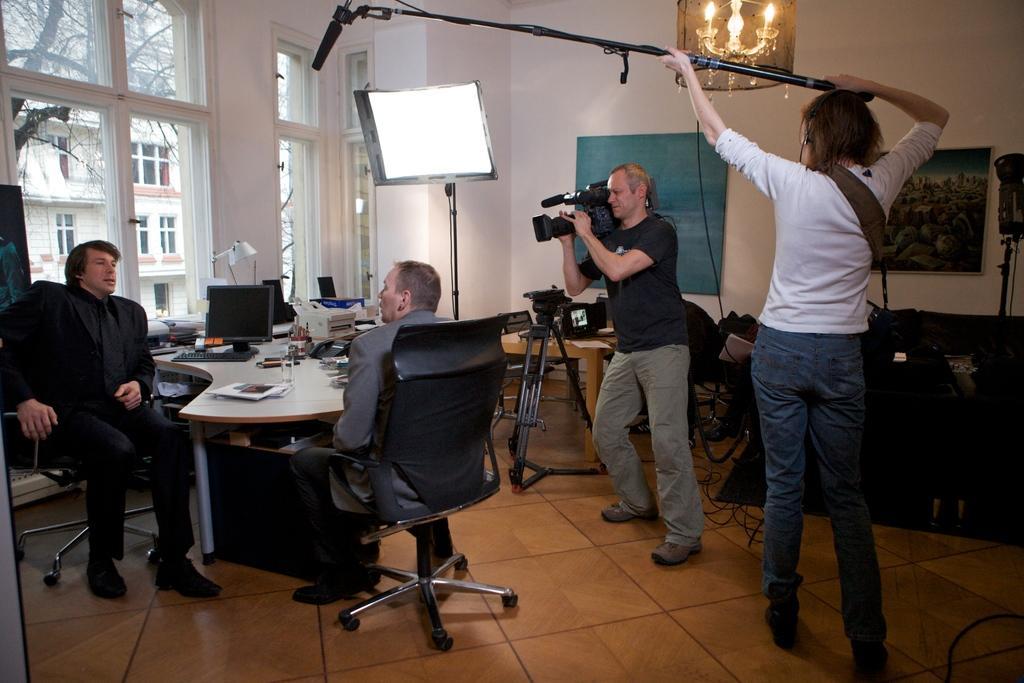How would you summarize this image in a sentence or two? There are four people in this picture. There are two men sitting in a chair. In between them there is a table. On the table there are monitor , keyboard, papers, lamps. The man with black t-shirt is standing and a holding video camera. The lady with white t-shirt is standing. To the left side there is a window. Behind the window there is a building and actress. Inside the room there is a frame, light and wires in the bottom. 